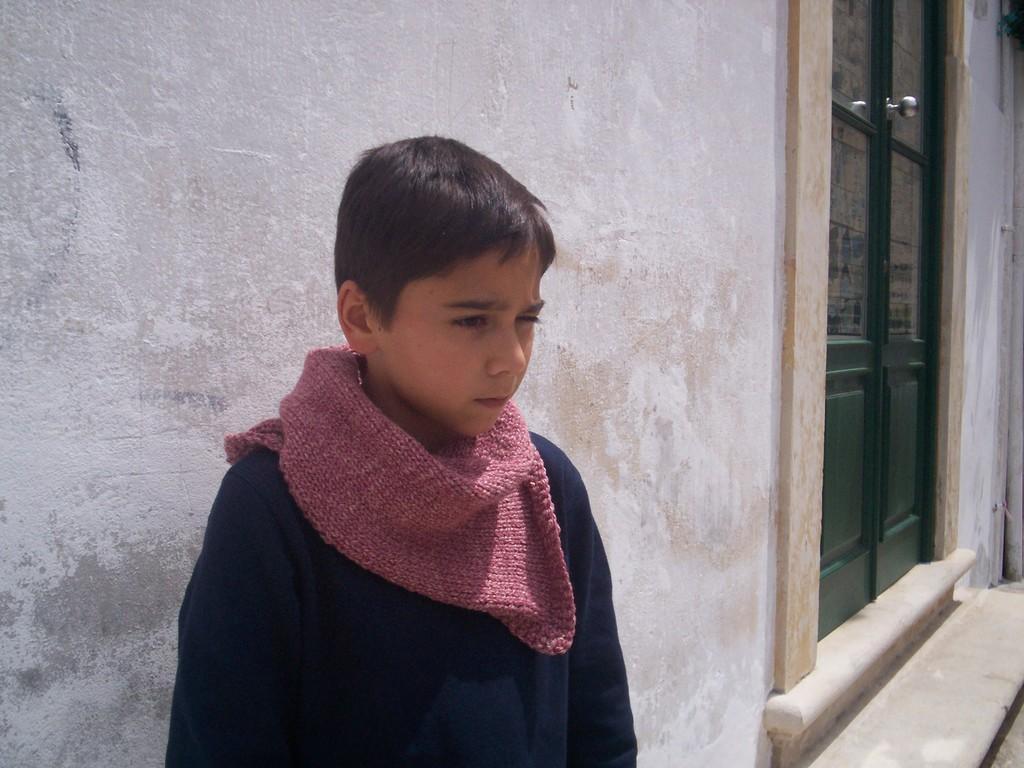Could you give a brief overview of what you see in this image? There is a boy standing in front of a wall and beside the wall there is a door. 